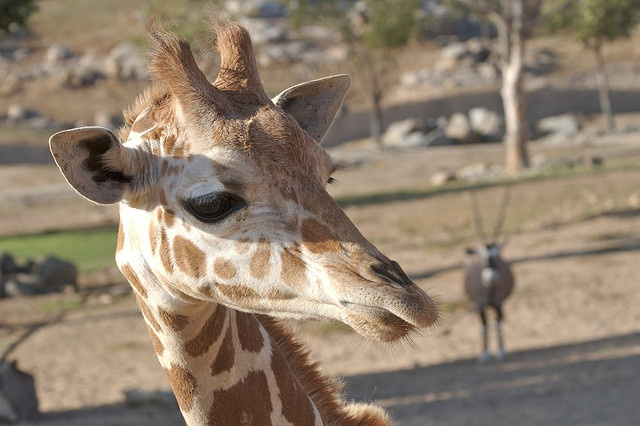Describe the objects in this image and their specific colors. I can see a giraffe in black, gray, maroon, and tan tones in this image. 